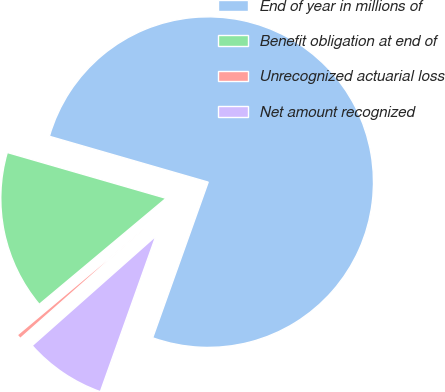Convert chart to OTSL. <chart><loc_0><loc_0><loc_500><loc_500><pie_chart><fcel>End of year in millions of<fcel>Benefit obligation at end of<fcel>Unrecognized actuarial loss<fcel>Net amount recognized<nl><fcel>75.98%<fcel>15.56%<fcel>0.45%<fcel>8.01%<nl></chart> 